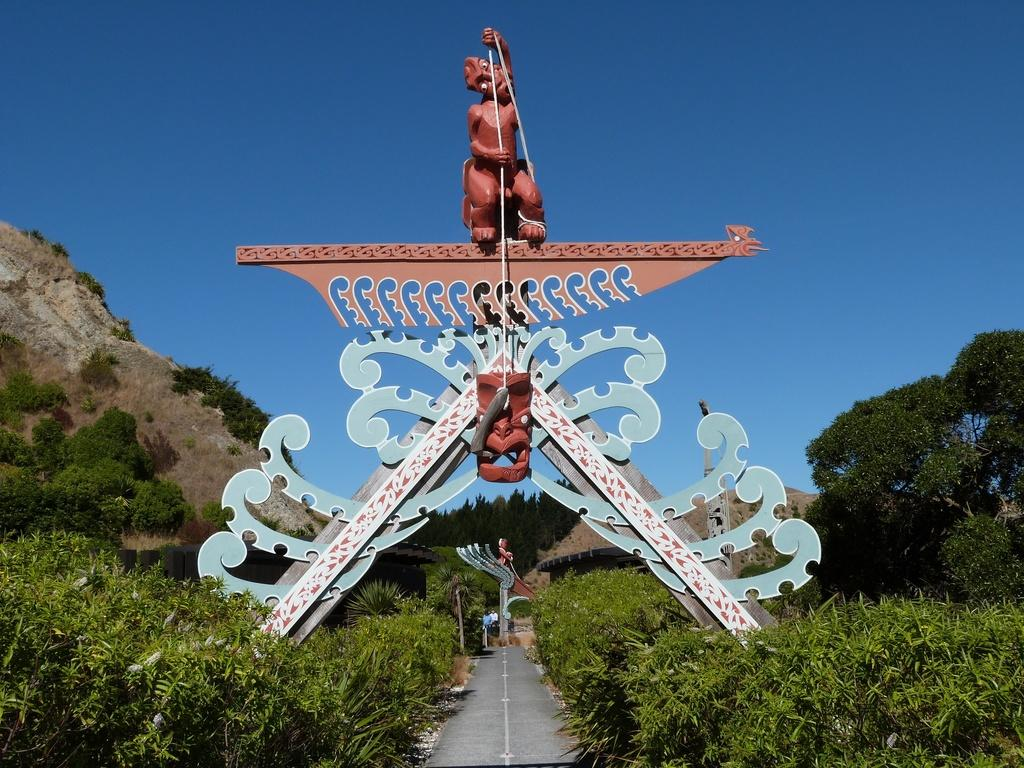What type of artwork is featured in the image? There is a wood carving sculpture in the image. What other elements can be seen at the bottom of the image? There are plants at the bottom of the image. What can be seen in the background of the image? There are trees, hills, and the sky visible in the background of the image. How many boys are playing with the oven in the image? There are no boys or ovens present in the image. What type of wind, zephyr, can be seen in the image? There is no mention of wind or zephyr in the image; it features a wood carving sculpture, plants, trees, hills, and the sky. 